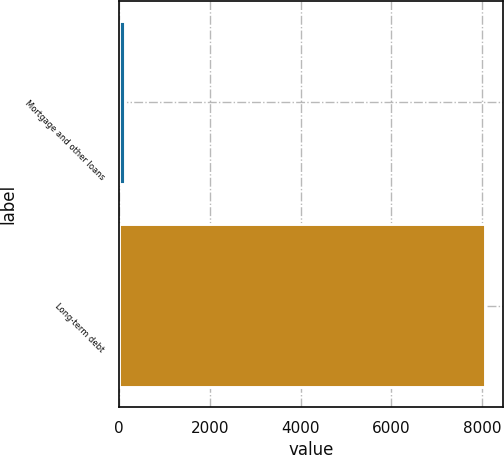Convert chart. <chart><loc_0><loc_0><loc_500><loc_500><bar_chart><fcel>Mortgage and other loans<fcel>Long-term debt<nl><fcel>134<fcel>8055<nl></chart> 